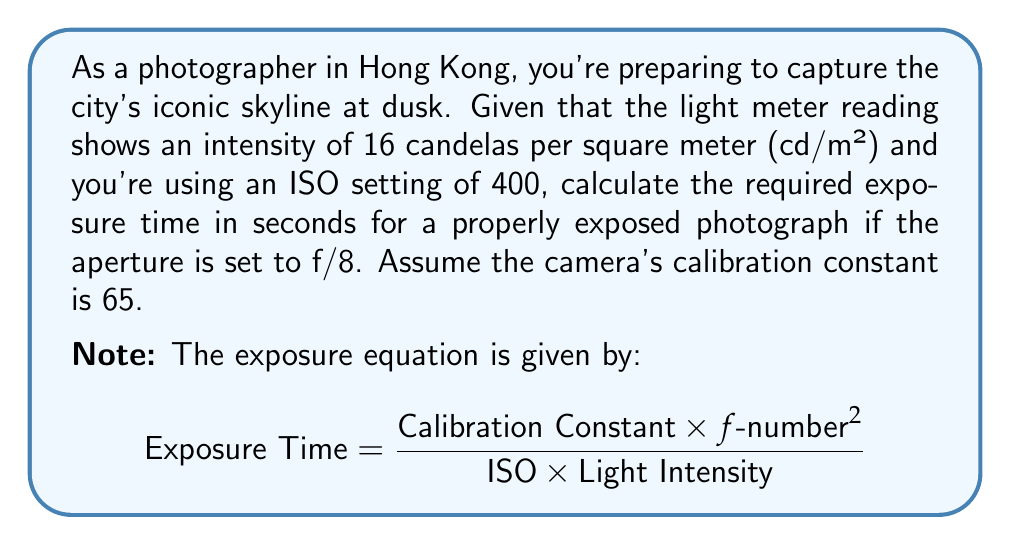Provide a solution to this math problem. To solve this problem, we'll use the exposure equation and plug in the given values:

1. Calibration Constant = 65
2. f-number = 8
3. ISO = 400
4. Light Intensity = 16 cd/m²

Let's substitute these values into the equation:

$$\text{Exposure Time} = \frac{65 \times 8^2}{400 \times 16}$$

Now, let's solve step by step:

1. Calculate $8^2$:
   $$8^2 = 64$$

2. Multiply the numerator:
   $$65 \times 64 = 4160$$

3. Multiply the denominator:
   $$400 \times 16 = 6400$$

4. Divide the numerator by the denominator:
   $$\frac{4160}{6400} = 0.65$$

Therefore, the required exposure time is 0.65 seconds.
Answer: 0.65 seconds 